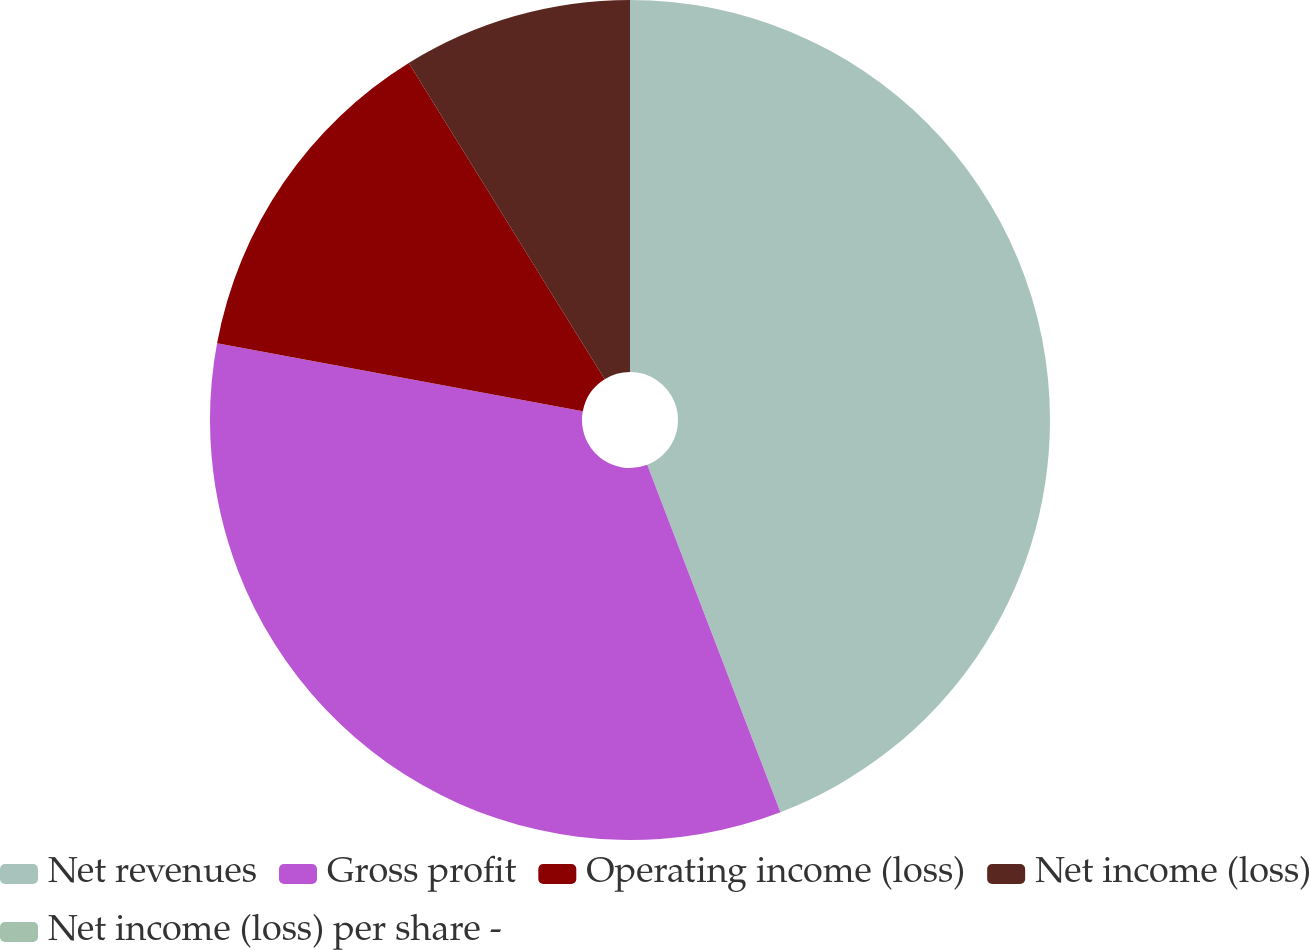Convert chart to OTSL. <chart><loc_0><loc_0><loc_500><loc_500><pie_chart><fcel>Net revenues<fcel>Gross profit<fcel>Operating income (loss)<fcel>Net income (loss)<fcel>Net income (loss) per share -<nl><fcel>44.17%<fcel>33.75%<fcel>13.25%<fcel>8.83%<fcel>0.0%<nl></chart> 